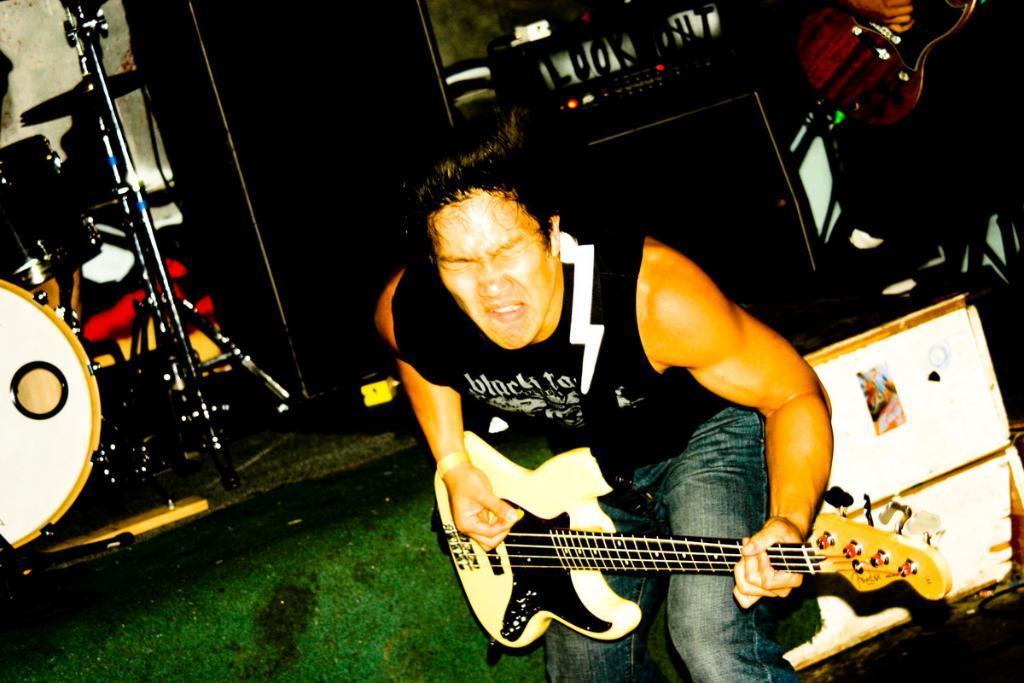Describe this image in one or two sentences. In the middle of the image a man playing guitar. In the top right side of the image a man holding the guitar. At the top of the image there is electronic device, Behind the electronic device there is a wall. In the top left side of the image there is a drum. 